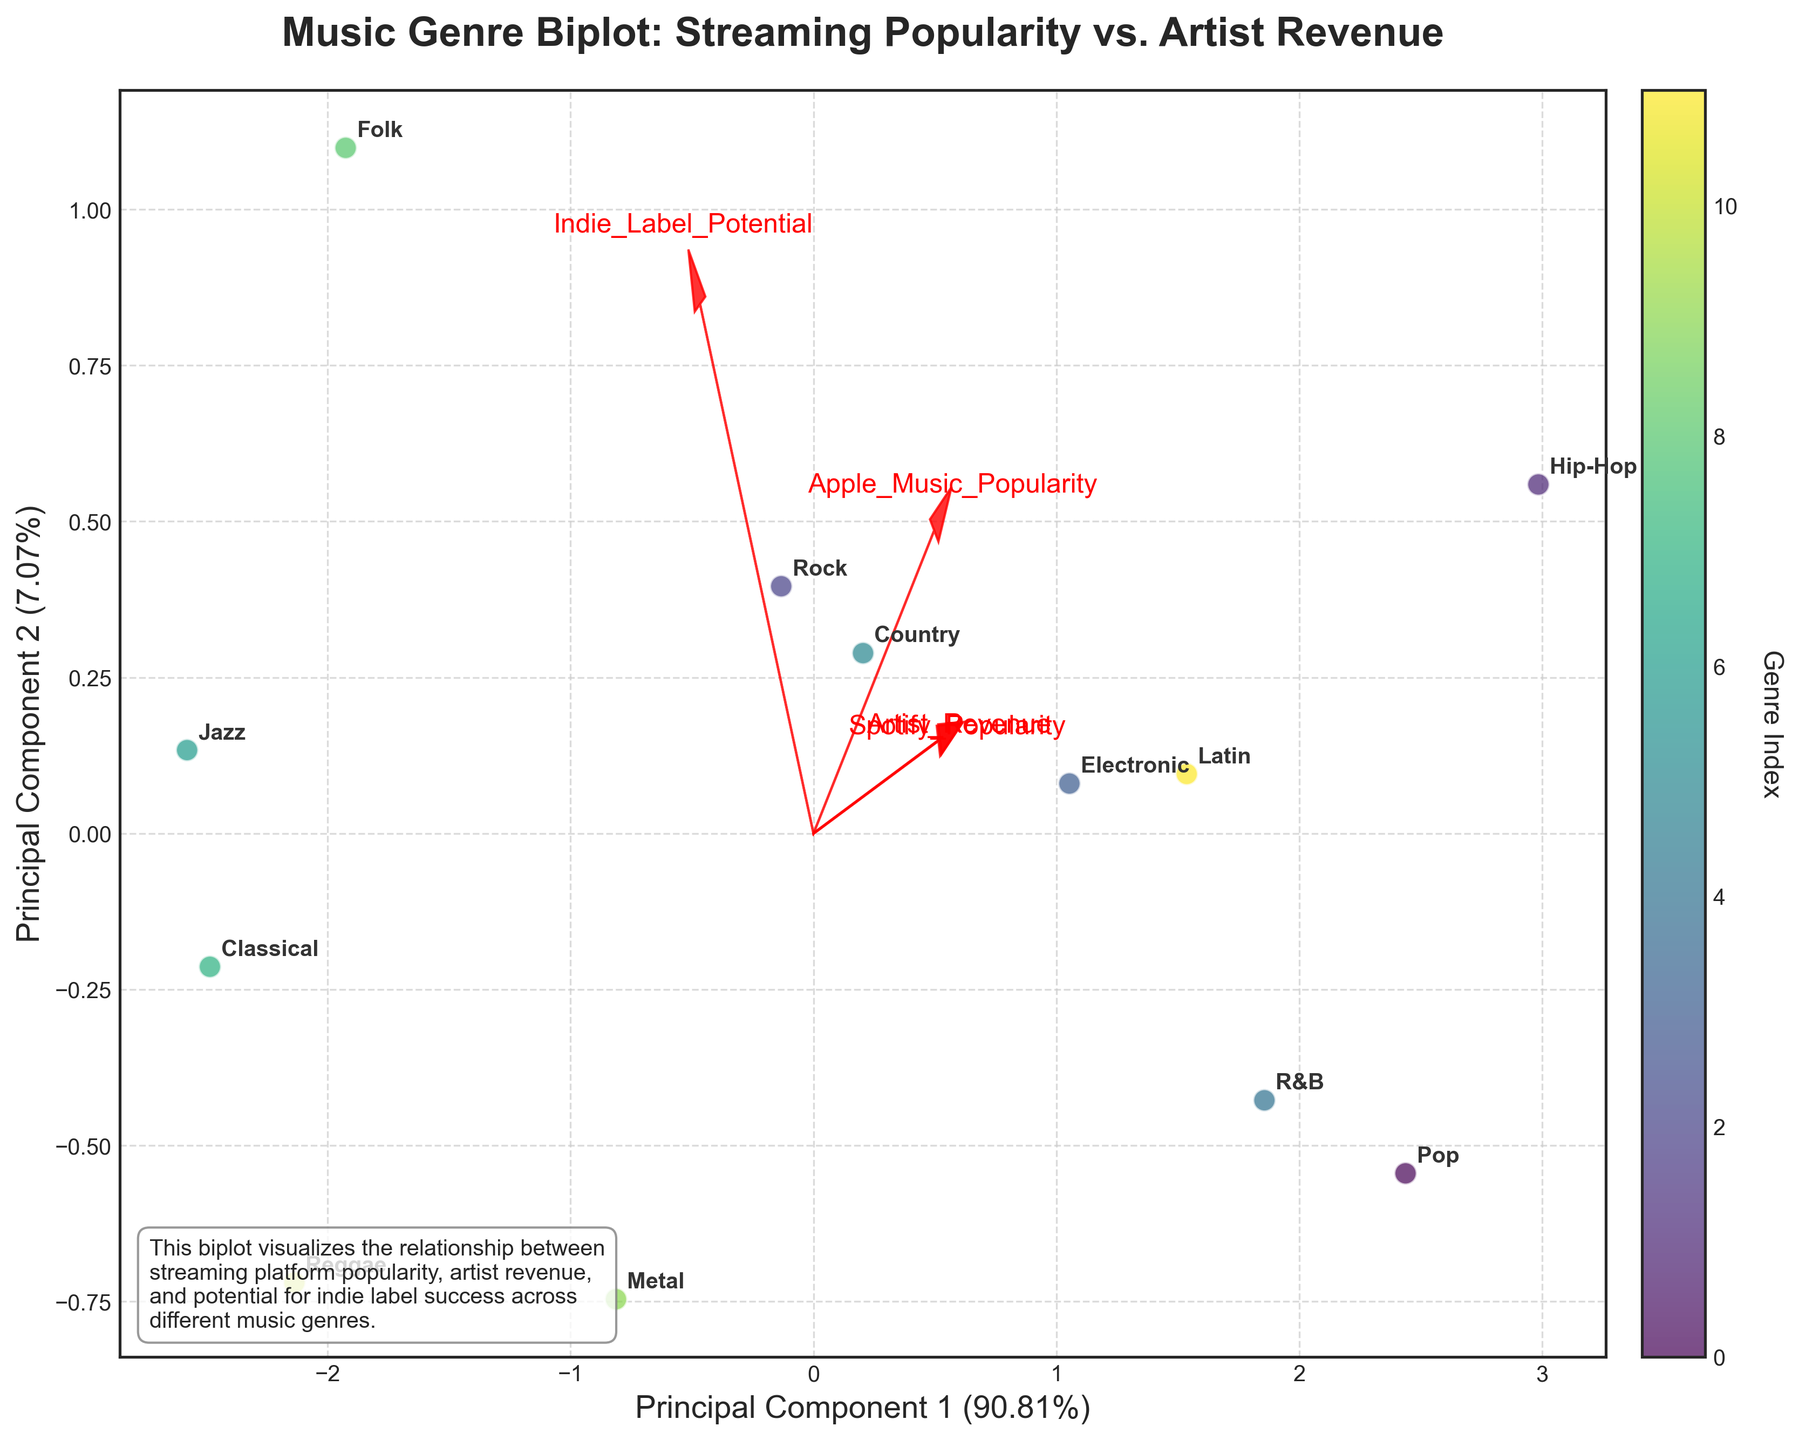What is the title of the biplot? The title is at the top of the figure, clearly indicating the focus of the plot. The title is "Music Genre Biplot: Streaming Popularity vs. Artist Revenue".
Answer: Music Genre Biplot: Streaming Popularity vs. Artist Revenue Which genre shows the highest Spotify popularity in the plot? The labels of the points represent the genres. The point with the highest Spotify popularity is annotated with "Hip-Hop".
Answer: Hip-Hop Which axes in the biplot represent principal components, and what do they indicate? The x-axis represents Principal Component 1, and the y-axis represents Principal Component 2. These axes represent the direction and magnitude of the principal components based on streaming popularity and artist revenue.
Answer: Principal Component 1 and Principal Component 2 Compare the positions of "Jazz" and "Classical" on the plot. Which one has higher principal component 2? Locate both "Jazz" and "Classical" labels. "Classical" is more elevated on the y-axis, indicating it has a higher principal component 2 value.
Answer: Classical Which genre is positioned closest to the origin in the biplot? The origin is where the principal component 1 and 2 axes intersect. "Reggae" appears closest to this point when compared to other genres.
Answer: Reggae How many genres fall above the x-axis indicating a positive value of principal component 2? Count the genres that appear above the x-axis. Genres like "Rock," "Electronic," "R&B," "Classical," and "Hip-Hop" reside above the axis.
Answer: 5 Are any genres located in the bottom-left quadrant of the biplot? If so, name them. The bottom-left quadrant is defined by negative values on both principal components axes. "Jazz" and "Reggae" are located in this quadrant.
Answer: Jazz and Reggae Which feature vectors have the most influence on Principal Component 1? The lengths of the arrows corresponding to each feature indicate their influence. The longest arrow along Principal Component 1 is for "Spotify_Popularity".
Answer: Spotify_Popularity Between "Country" and "Latin," which genre shows a higher Apple Music popularity according to the directions of feature vectors? By following the direction of the "Apple_Music_Popularity" vector, observe the relative positions. "Latin" is closer and more aligned with this direction than "Country".
Answer: Latin What information is provided in the additional text box on the plot? The text box summarizes what the biplot visualizes, explaining the relationship between streaming popularity, artist revenue, and indie label potential across genres.
Answer: Visualizes streaming popularity, artist revenue, and indie label potential across genres 